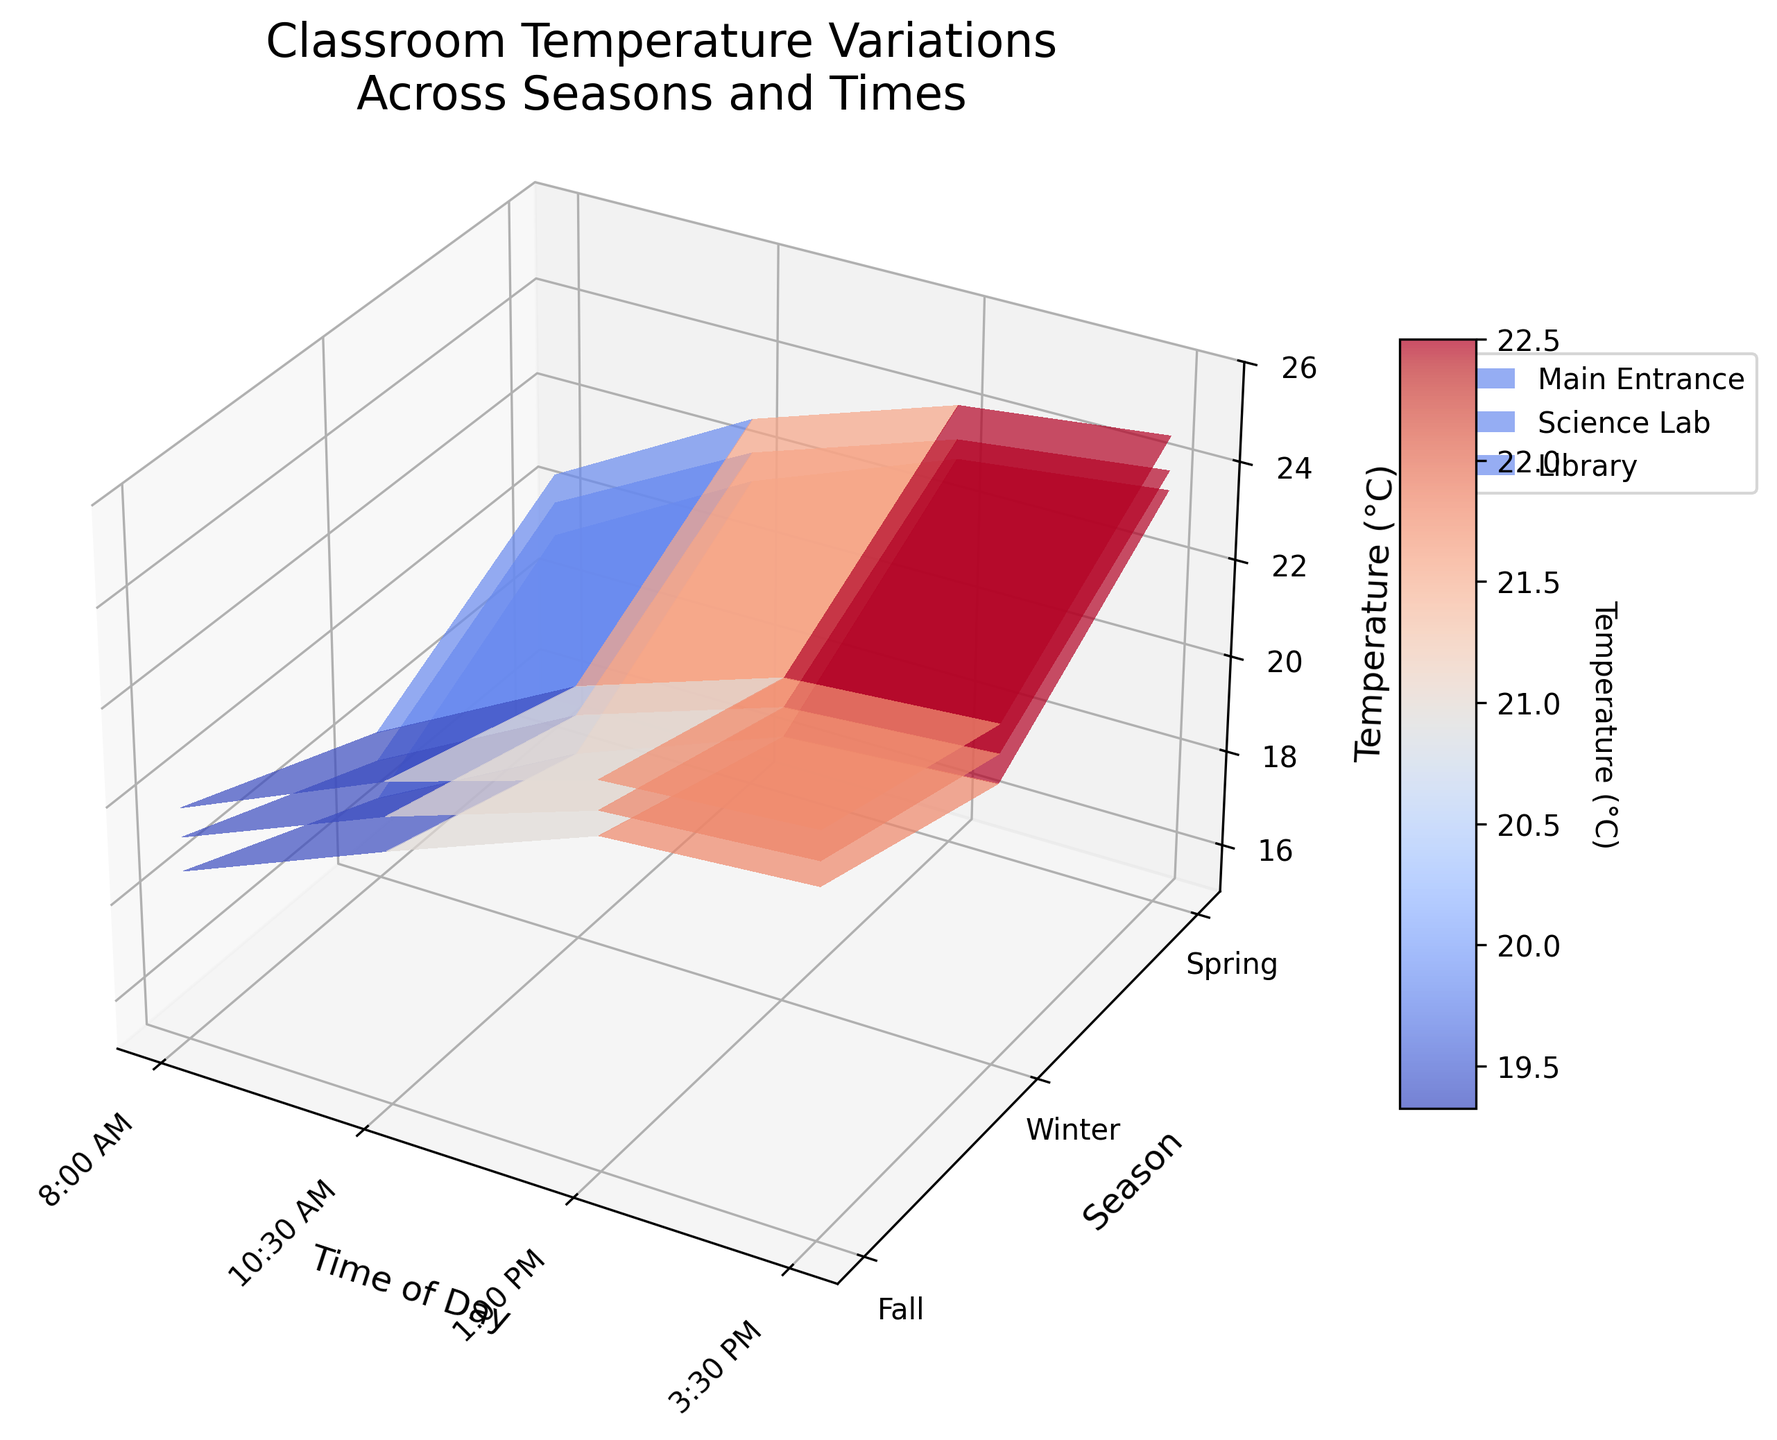What is the title of the figure? The title is the text displayed at the top of the figure
Answer: "Classroom Temperature Variations Across Seasons and Times" What are the labels on the x-axis, y-axis, and z-axis? The labels are the text indicating the respective axis information. For the x-axis: 'Time of Day', y-axis: 'Season', and z-axis: 'Temperature (°C)'.
Answer: 'Time of Day', 'Season', 'Temperature (°C)' Which season shows the highest temperature in the Science Lab at 3:30 PM? Locate the highest z-coordinate for the Science Lab's surface plot at the 3:30 PM x-coordinate, then check the corresponding y-coordinate for the season.
Answer: Spring Which location has the lowest temperature at 8:00 AM in Winter? Find the lowest z-value at the 8:00 AM x-coordinate for Winter on each surface plot and identify which plot (location) it belongs to.
Answer: Main Entrance How does the temperature at the Main Entrance change from 8:00 AM to 3:30 PM during Fall? Follow the surface plot for the Main Entrance from the 8:00 AM to the 3:30 PM x-coordinates and observe the variation in the z-values over this range.
Answer: The temperature increases from 18.5°C to 22.1°C Which location has the most uniform temperature change throughout the day in Winter? Observe the z-values along the x-axis for each location's winter surface plot and identify which has the smallest variation.
Answer: Main Entrance Among the three locations, which one is warmest during Spring at 10:30 AM? Compare the z-values at the 10:30 AM x-coordinate for Spring across all three locations' surface plots and find the highest one.
Answer: Science Lab Is there any location where the temperature stays below 20°C throughout Fall? Check the z-values across all x-coordinates in Fall for each location's surface plot, looking for one where all values are below 20°C.
Answer: No What is the general trend of temperature change for all locations as the day progresses? Observe how the z-values change from 8:00 AM to 3:30 PM across all surface plots.
Answer: The temperature generally increases 